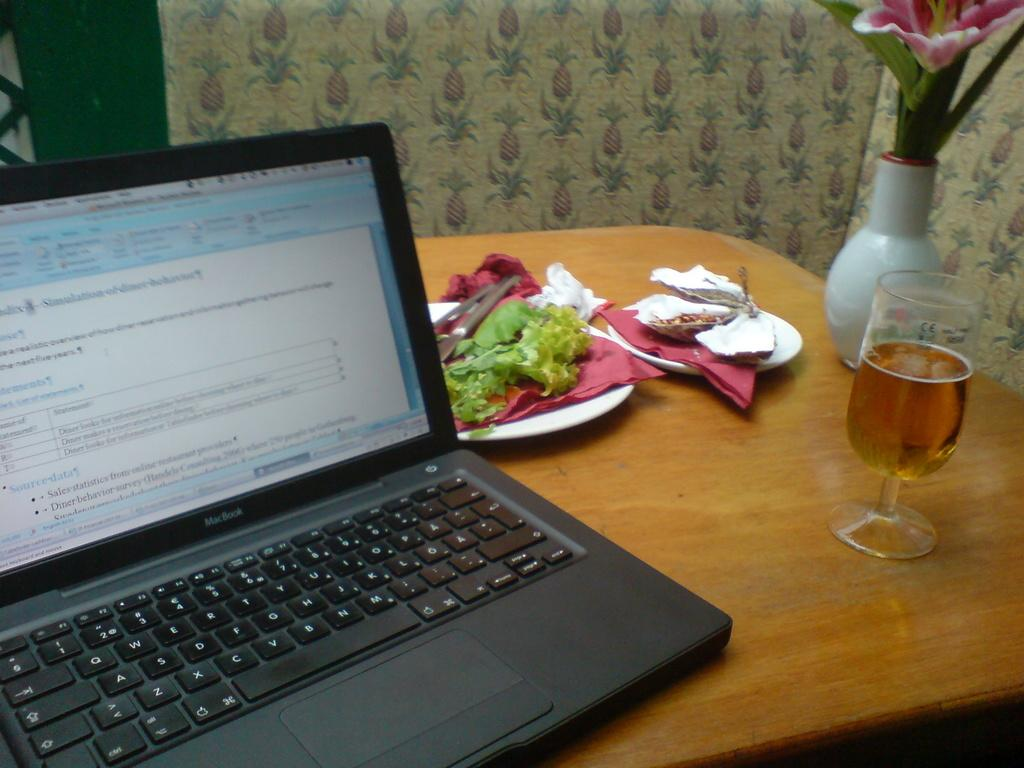What is placed on the table in the image? There is a vase with flowers, a glass with liquid, plates, a laptop, and food on the table. What can be found inside the vase on the table? The vase on the table contains flowers. What is in the glass on the table? The glass on the table contains liquid. What type of electronic device is on the table? There is a laptop on the table. What might be used for eating on the table? The plates on the table might be used for eating. What type of punishment is being administered to the laptop in the image? There is no punishment being administered to the laptop in the image; it is simply placed on the table. How does the rainstorm affect the food on the table? There is no rainstorm present in the image, so it cannot affect the food on the table. 